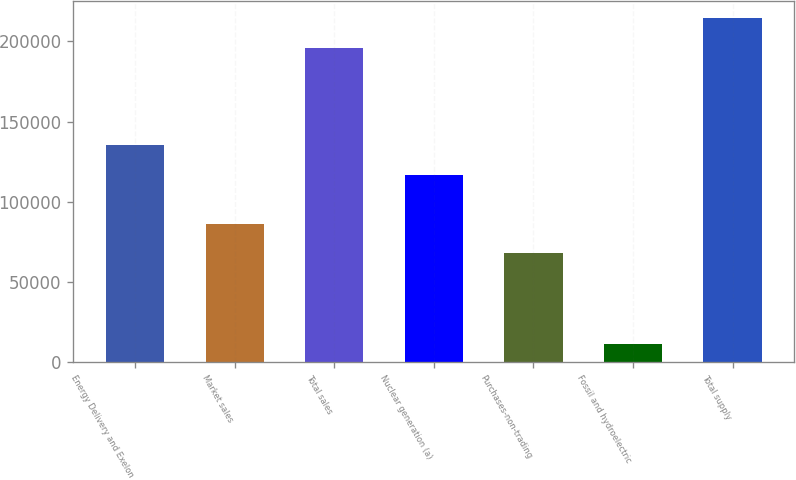<chart> <loc_0><loc_0><loc_500><loc_500><bar_chart><fcel>Energy Delivery and Exelon<fcel>Market sales<fcel>Total sales<fcel>Nuclear generation (a)<fcel>Purchases-non-trading<fcel>Fossil and hydroelectric<fcel>Total supply<nl><fcel>135317<fcel>86420.1<fcel>196126<fcel>116839<fcel>67942<fcel>11345<fcel>214604<nl></chart> 